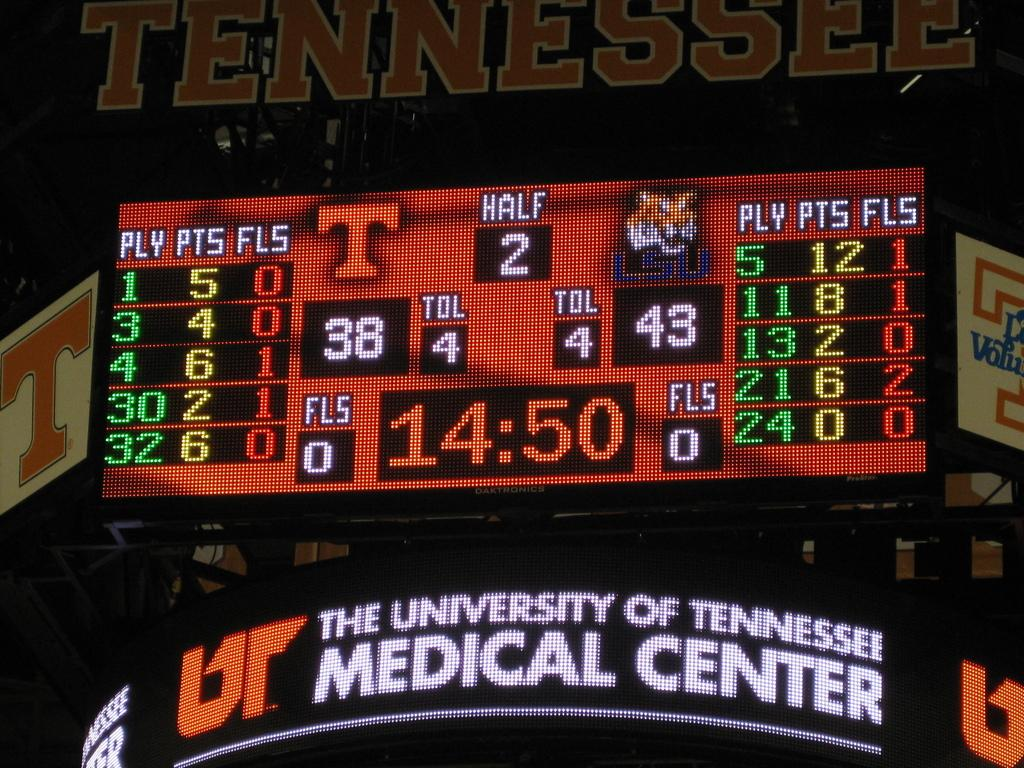<image>
Describe the image concisely. a sports billboard with the time reading 14:50 and the word Tennessee 